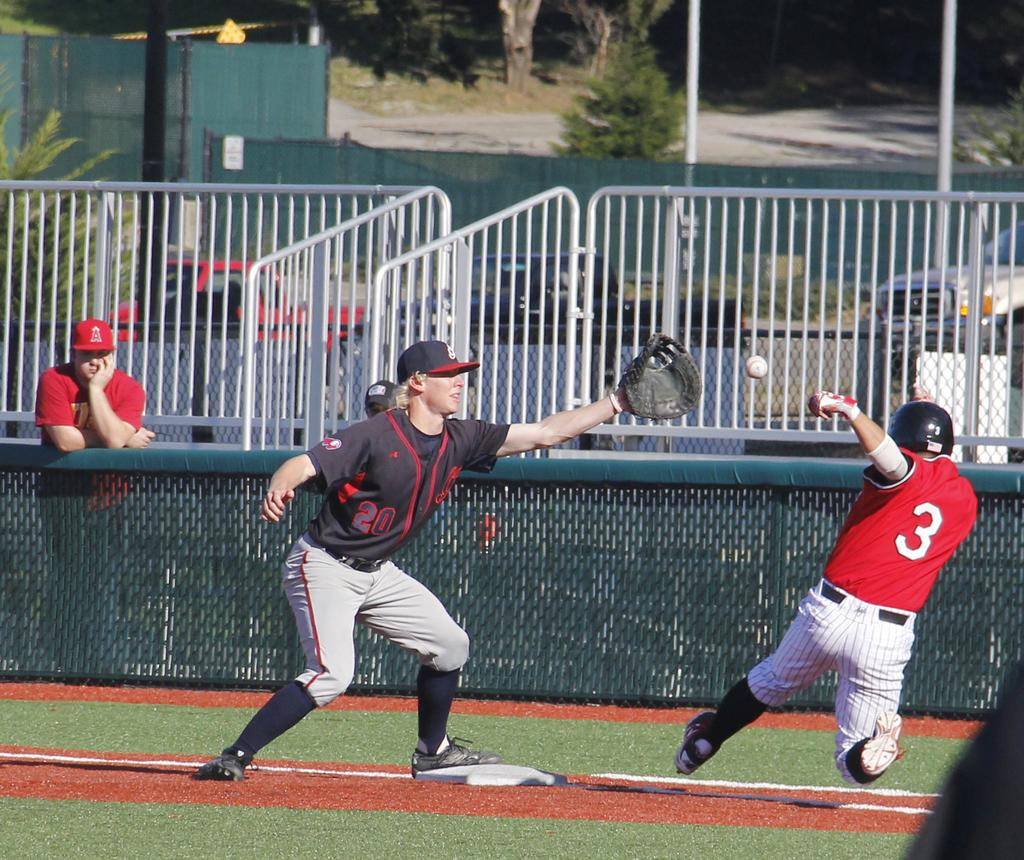<image>
Summarize the visual content of the image. Player number 3 hopes to slide into first base before number 20 on the opposing team can tag him out. 